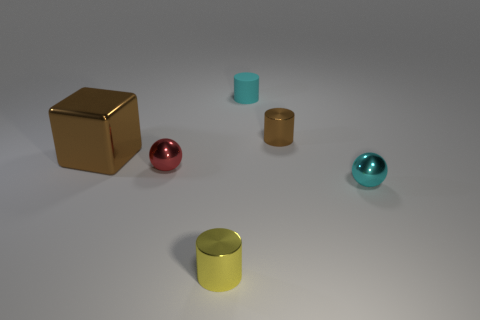Add 3 tiny brown metallic things. How many objects exist? 9 Subtract all balls. How many objects are left? 4 Add 6 yellow shiny things. How many yellow shiny things are left? 7 Add 1 small yellow blocks. How many small yellow blocks exist? 1 Subtract 0 brown spheres. How many objects are left? 6 Subtract all large yellow shiny spheres. Subtract all big brown metal things. How many objects are left? 5 